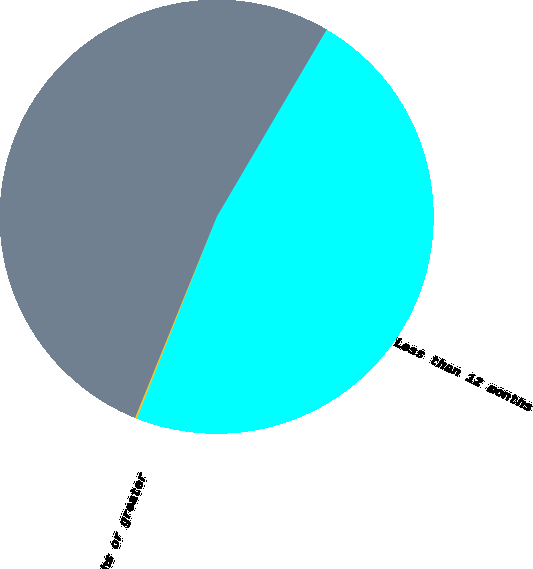<chart> <loc_0><loc_0><loc_500><loc_500><pie_chart><fcel>Less than 12 months<fcel>12 months or greater<fcel>Total<nl><fcel>47.55%<fcel>0.14%<fcel>52.31%<nl></chart> 